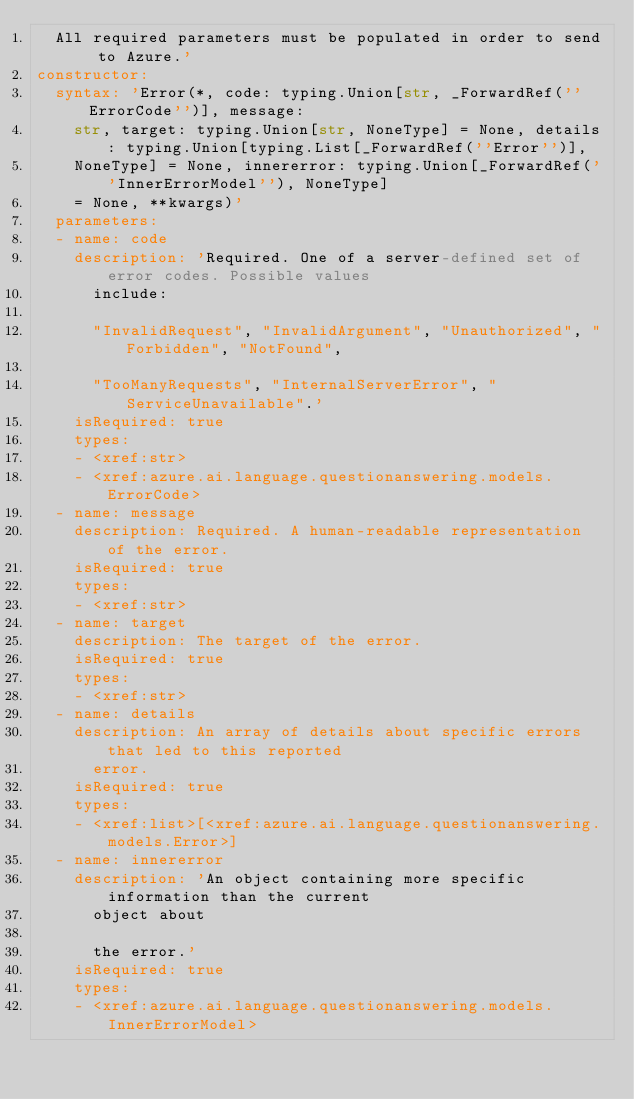Convert code to text. <code><loc_0><loc_0><loc_500><loc_500><_YAML_>  All required parameters must be populated in order to send to Azure.'
constructor:
  syntax: 'Error(*, code: typing.Union[str, _ForwardRef(''ErrorCode'')], message:
    str, target: typing.Union[str, NoneType] = None, details: typing.Union[typing.List[_ForwardRef(''Error'')],
    NoneType] = None, innererror: typing.Union[_ForwardRef(''InnerErrorModel''), NoneType]
    = None, **kwargs)'
  parameters:
  - name: code
    description: 'Required. One of a server-defined set of error codes. Possible values
      include:

      "InvalidRequest", "InvalidArgument", "Unauthorized", "Forbidden", "NotFound",

      "TooManyRequests", "InternalServerError", "ServiceUnavailable".'
    isRequired: true
    types:
    - <xref:str>
    - <xref:azure.ai.language.questionanswering.models.ErrorCode>
  - name: message
    description: Required. A human-readable representation of the error.
    isRequired: true
    types:
    - <xref:str>
  - name: target
    description: The target of the error.
    isRequired: true
    types:
    - <xref:str>
  - name: details
    description: An array of details about specific errors that led to this reported
      error.
    isRequired: true
    types:
    - <xref:list>[<xref:azure.ai.language.questionanswering.models.Error>]
  - name: innererror
    description: 'An object containing more specific information than the current
      object about

      the error.'
    isRequired: true
    types:
    - <xref:azure.ai.language.questionanswering.models.InnerErrorModel>
</code> 